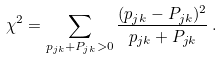Convert formula to latex. <formula><loc_0><loc_0><loc_500><loc_500>\chi ^ { 2 } = \sum _ { p _ { j k } + P _ { j k } > 0 } \frac { ( p _ { j k } - P _ { j k } ) ^ { 2 } } { p _ { j k } + P _ { j k } } \, .</formula> 